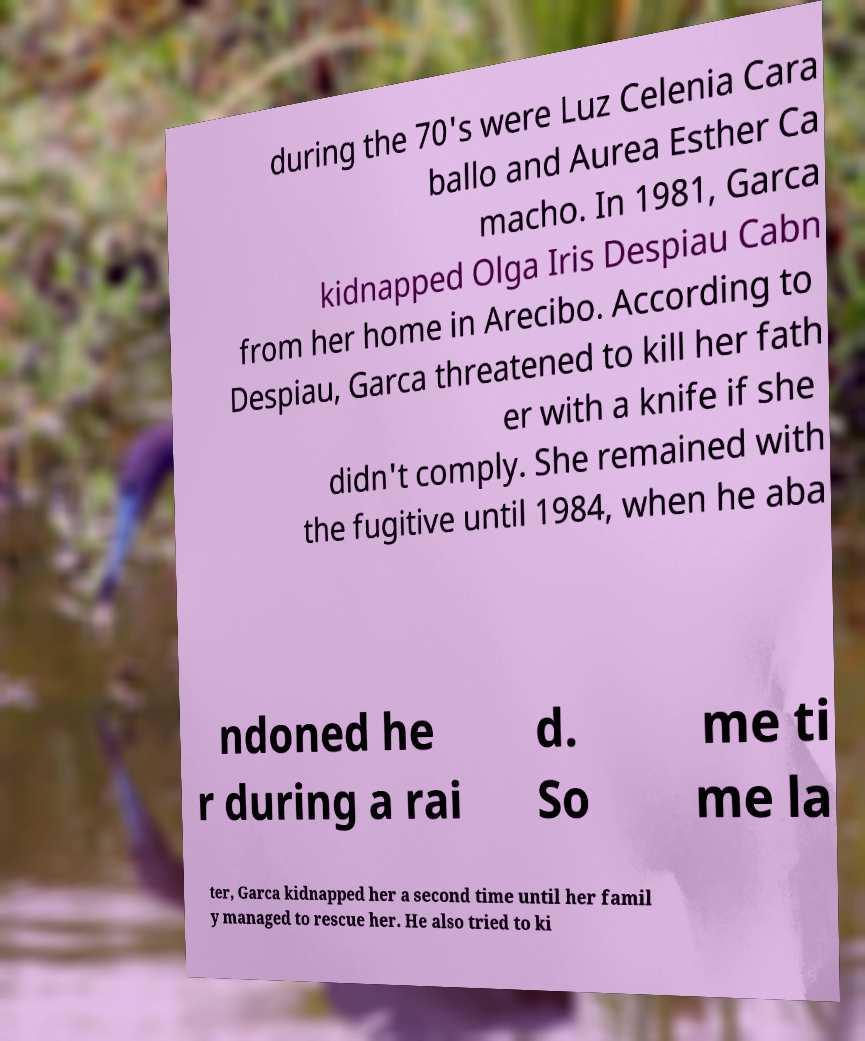I need the written content from this picture converted into text. Can you do that? during the 70's were Luz Celenia Cara ballo and Aurea Esther Ca macho. In 1981, Garca kidnapped Olga Iris Despiau Cabn from her home in Arecibo. According to Despiau, Garca threatened to kill her fath er with a knife if she didn't comply. She remained with the fugitive until 1984, when he aba ndoned he r during a rai d. So me ti me la ter, Garca kidnapped her a second time until her famil y managed to rescue her. He also tried to ki 